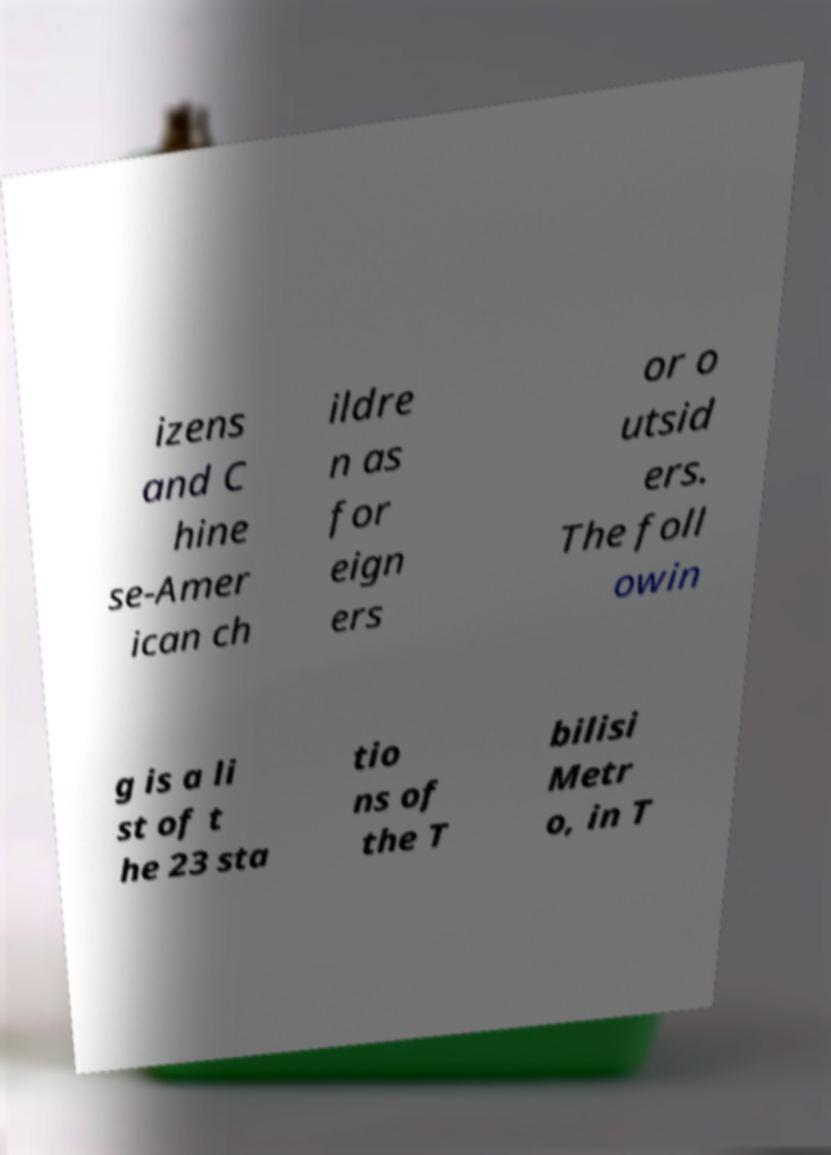For documentation purposes, I need the text within this image transcribed. Could you provide that? izens and C hine se-Amer ican ch ildre n as for eign ers or o utsid ers. The foll owin g is a li st of t he 23 sta tio ns of the T bilisi Metr o, in T 